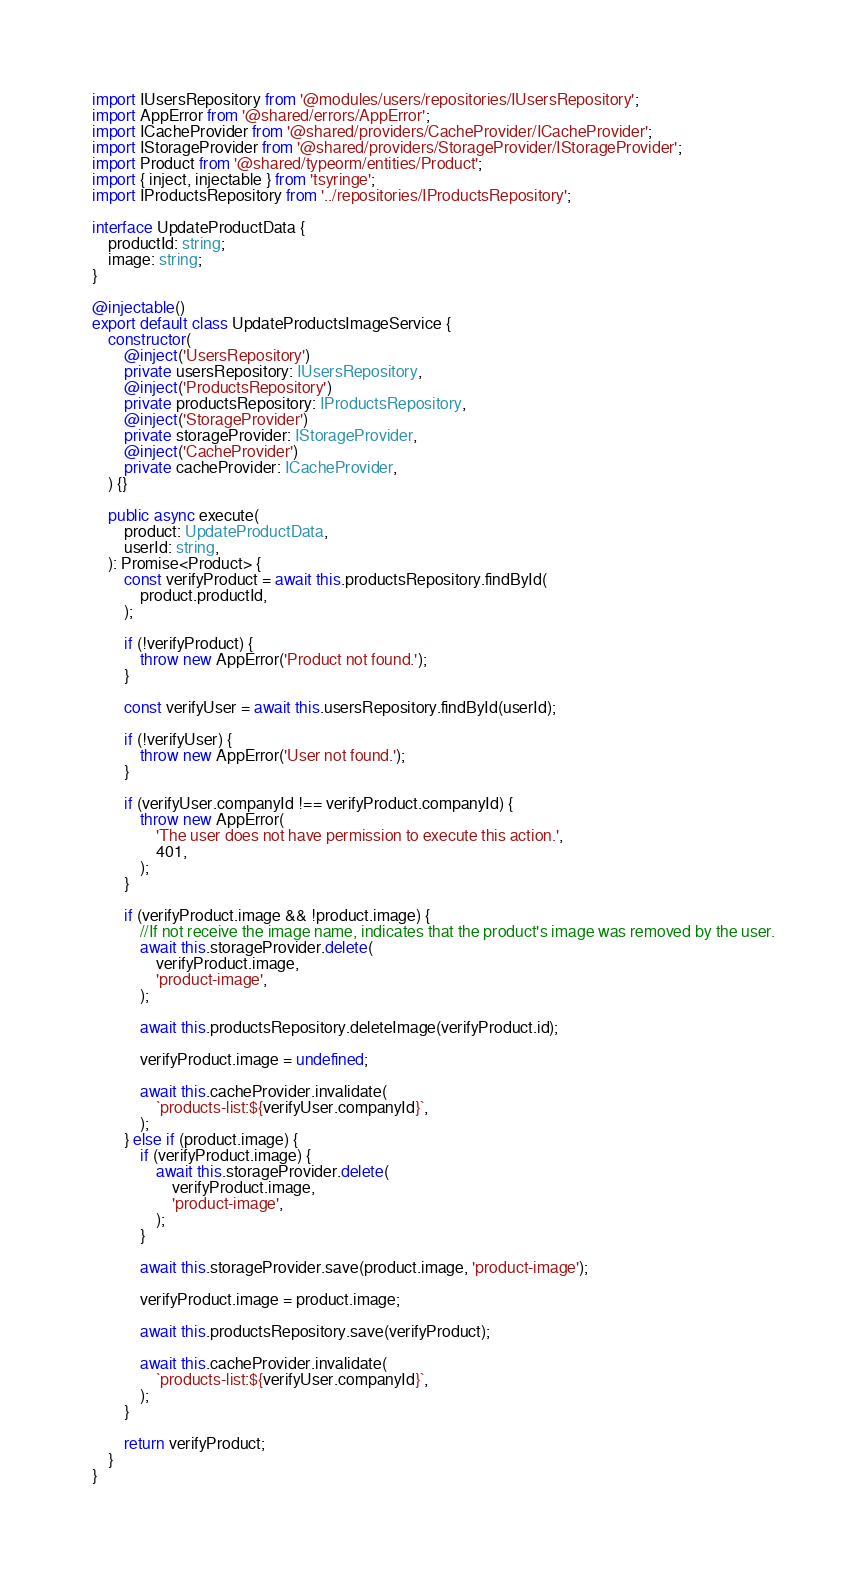<code> <loc_0><loc_0><loc_500><loc_500><_TypeScript_>import IUsersRepository from '@modules/users/repositories/IUsersRepository';
import AppError from '@shared/errors/AppError';
import ICacheProvider from '@shared/providers/CacheProvider/ICacheProvider';
import IStorageProvider from '@shared/providers/StorageProvider/IStorageProvider';
import Product from '@shared/typeorm/entities/Product';
import { inject, injectable } from 'tsyringe';
import IProductsRepository from '../repositories/IProductsRepository';

interface UpdateProductData {
    productId: string;
    image: string;
}

@injectable()
export default class UpdateProductsImageService {
    constructor(
        @inject('UsersRepository')
        private usersRepository: IUsersRepository,
        @inject('ProductsRepository')
        private productsRepository: IProductsRepository,
        @inject('StorageProvider')
        private storageProvider: IStorageProvider,
        @inject('CacheProvider')
        private cacheProvider: ICacheProvider,
    ) {}

    public async execute(
        product: UpdateProductData,
        userId: string,
    ): Promise<Product> {
        const verifyProduct = await this.productsRepository.findById(
            product.productId,
        );

        if (!verifyProduct) {
            throw new AppError('Product not found.');
        }

        const verifyUser = await this.usersRepository.findById(userId);

        if (!verifyUser) {
            throw new AppError('User not found.');
        }

        if (verifyUser.companyId !== verifyProduct.companyId) {
            throw new AppError(
                'The user does not have permission to execute this action.',
                401,
            );
        }

        if (verifyProduct.image && !product.image) {
            //If not receive the image name, indicates that the product's image was removed by the user.
            await this.storageProvider.delete(
                verifyProduct.image,
                'product-image',
            );

            await this.productsRepository.deleteImage(verifyProduct.id);

            verifyProduct.image = undefined;

            await this.cacheProvider.invalidate(
                `products-list:${verifyUser.companyId}`,
            );
        } else if (product.image) {
            if (verifyProduct.image) {
                await this.storageProvider.delete(
                    verifyProduct.image,
                    'product-image',
                );
            }

            await this.storageProvider.save(product.image, 'product-image');

            verifyProduct.image = product.image;

            await this.productsRepository.save(verifyProduct);

            await this.cacheProvider.invalidate(
                `products-list:${verifyUser.companyId}`,
            );
        }

        return verifyProduct;
    }
}
</code> 